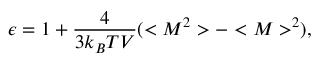<formula> <loc_0><loc_0><loc_500><loc_500>\epsilon = 1 + \frac { 4 } { 3 k _ { B } T V } ( < M ^ { 2 } > - < M > ^ { 2 } ) ,</formula> 